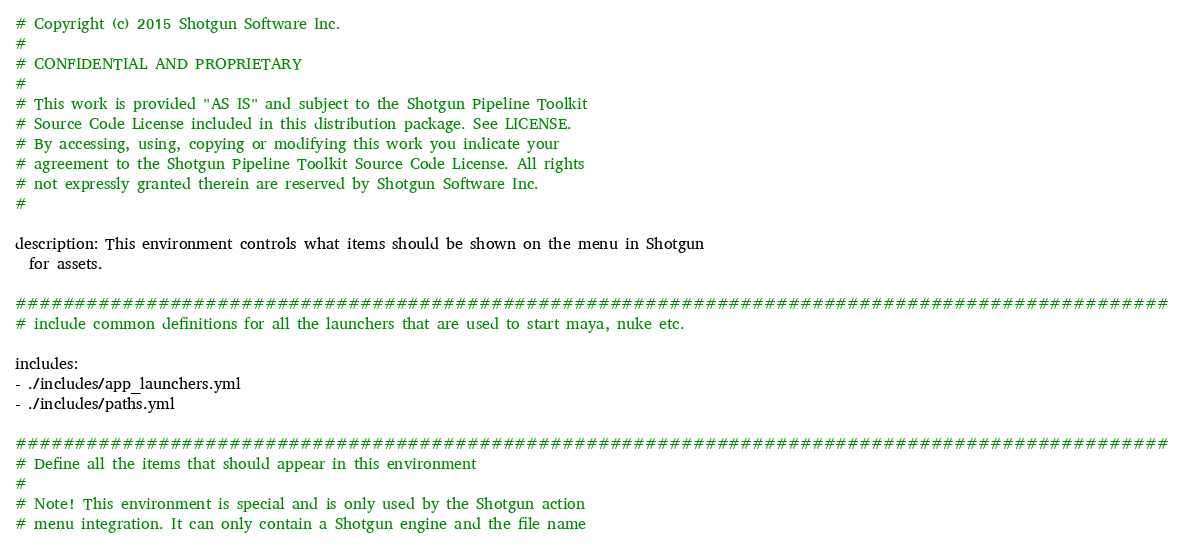Convert code to text. <code><loc_0><loc_0><loc_500><loc_500><_YAML_># Copyright (c) 2015 Shotgun Software Inc.
#
# CONFIDENTIAL AND PROPRIETARY
#
# This work is provided "AS IS" and subject to the Shotgun Pipeline Toolkit
# Source Code License included in this distribution package. See LICENSE.
# By accessing, using, copying or modifying this work you indicate your
# agreement to the Shotgun Pipeline Toolkit Source Code License. All rights
# not expressly granted therein are reserved by Shotgun Software Inc.
#

description: This environment controls what items should be shown on the menu in Shotgun
  for assets.

#################################################################################################
# include common definitions for all the launchers that are used to start maya, nuke etc.

includes:
- ./includes/app_launchers.yml
- ./includes/paths.yml

#################################################################################################
# Define all the items that should appear in this environment
#
# Note! This environment is special and is only used by the Shotgun action
# menu integration. It can only contain a Shotgun engine and the file name</code> 